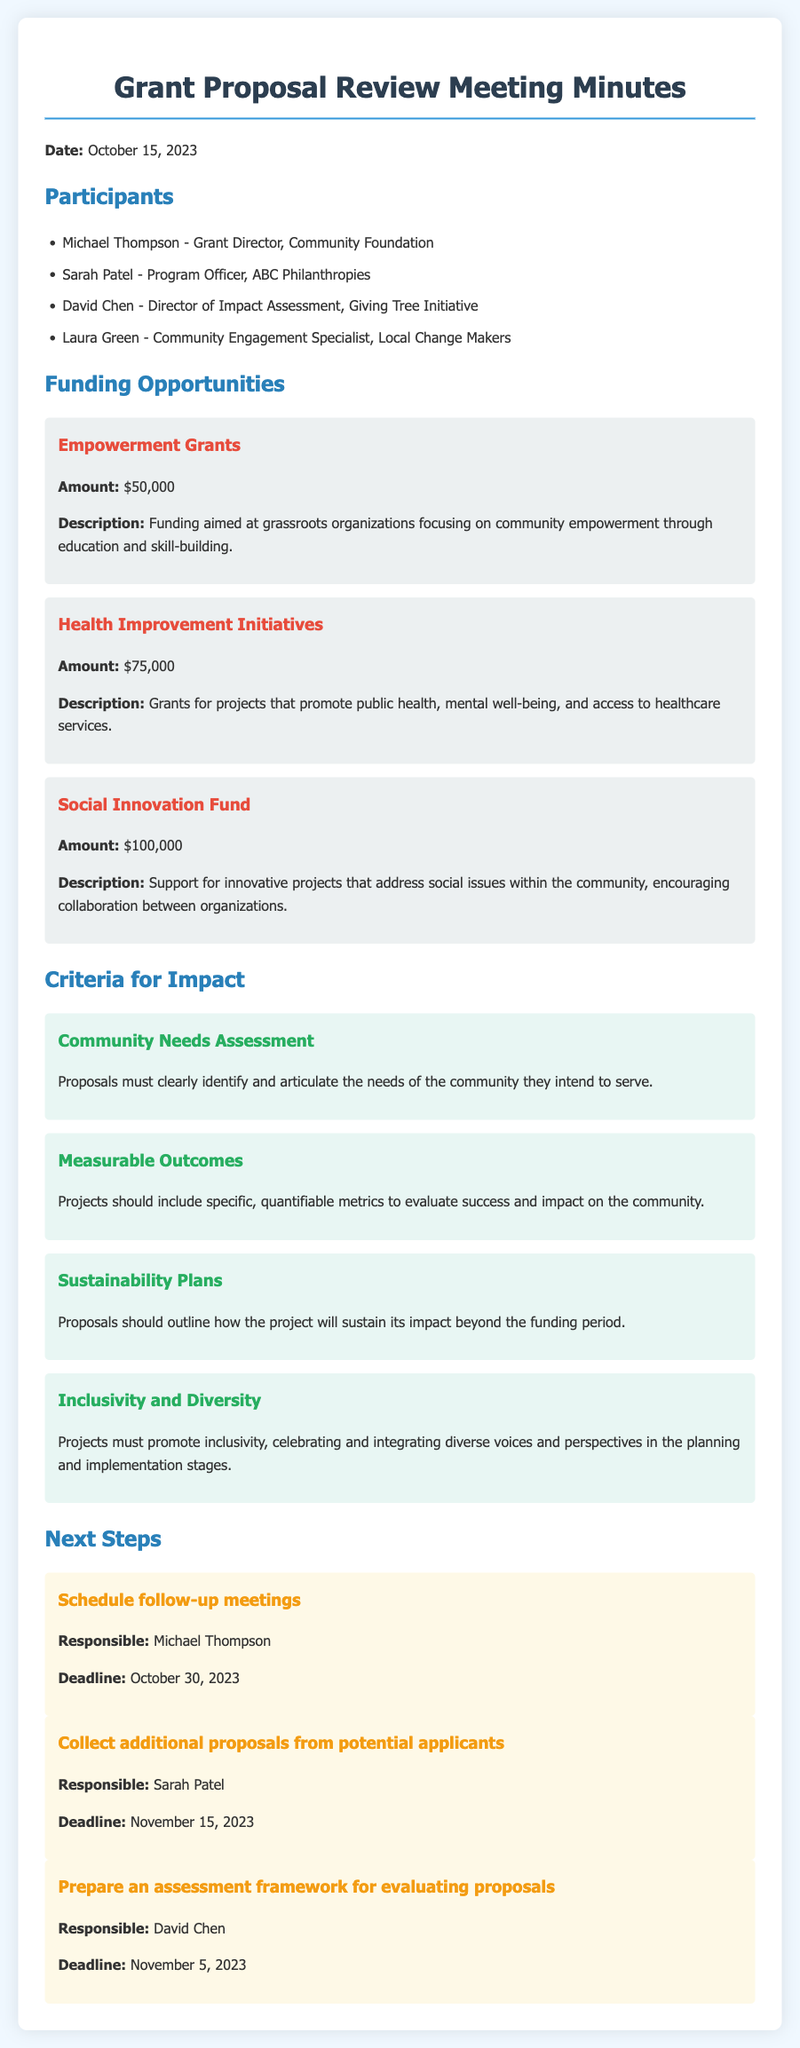What is the date of the meeting? The date of the meeting is mentioned in the introduction section of the document.
Answer: October 15, 2023 Who is responsible for scheduling follow-up meetings? The individual responsible for scheduling follow-up meetings is identified in the next steps section.
Answer: Michael Thompson What is the amount for Health Improvement Initiatives? The amount for this funding opportunity is stated under the funding opportunities section.
Answer: $75,000 What is one criterion for impact relating to community needs? A specific requirement for proposals is noted in the criteria for impact section.
Answer: Community Needs Assessment What is the deadline for collecting additional proposals? The deadline for this task is specified in the next steps section.
Answer: November 15, 2023 How many participants were listed in the meeting? The number of participants can be counted from the participants section.
Answer: 4 What is the title of the funding opportunity offering $100,000? The title of this grant is mentioned in the funding opportunities section.
Answer: Social Innovation Fund What type of projects do Empowerment Grants focus on? The description of this funding opportunity explains its focus.
Answer: Community empowerment through education and skill-building 